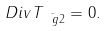<formula> <loc_0><loc_0><loc_500><loc_500>\ D i v T _ { \bar { \ g 2 } } = 0 .</formula> 